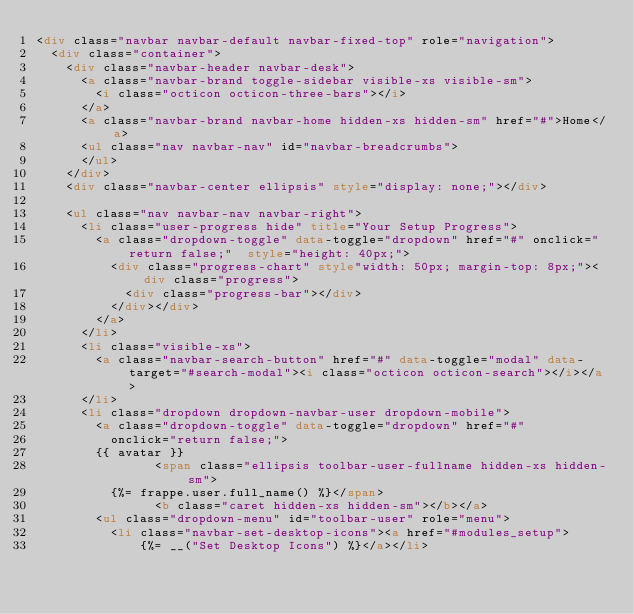<code> <loc_0><loc_0><loc_500><loc_500><_HTML_><div class="navbar navbar-default navbar-fixed-top" role="navigation">
	<div class="container">
		<div class="navbar-header navbar-desk">
			<a class="navbar-brand toggle-sidebar visible-xs visible-sm">
				<i class="octicon octicon-three-bars"></i>
			</a>
			<a class="navbar-brand navbar-home hidden-xs hidden-sm" href="#">Home</a>
			<ul class="nav navbar-nav" id="navbar-breadcrumbs">
			</ul>
		</div>
		<div class="navbar-center ellipsis" style="display: none;"></div>

		<ul class="nav navbar-nav navbar-right">
			<li class="user-progress hide" title="Your Setup Progress">
				<a class="dropdown-toggle" data-toggle="dropdown" href="#" onclick="return false;"  style="height: 40px;">
					<div class="progress-chart" style"width: 50px; margin-top: 8px;"><div class="progress">
						<div class="progress-bar"></div>
					</div></div>
				</a>
			</li>
			<li class="visible-xs">
				<a class="navbar-search-button" href="#" data-toggle="modal" data-target="#search-modal"><i class="octicon octicon-search"></i></a>
			</li>
			<li class="dropdown dropdown-navbar-user dropdown-mobile">
				<a class="dropdown-toggle" data-toggle="dropdown" href="#"
					onclick="return false;">
				{{ avatar }}
                <span class="ellipsis toolbar-user-fullname hidden-xs hidden-sm">
					{%= frappe.user.full_name() %}</span>
                <b class="caret hidden-xs hidden-sm"></b></a>
				<ul class="dropdown-menu" id="toolbar-user" role="menu">
					<li class="navbar-set-desktop-icons"><a href="#modules_setup">
					    {%= __("Set Desktop Icons") %}</a></li></code> 